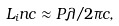Convert formula to latex. <formula><loc_0><loc_0><loc_500><loc_500>L _ { i } n c \approx P \lambda / 2 \pi c ,</formula> 